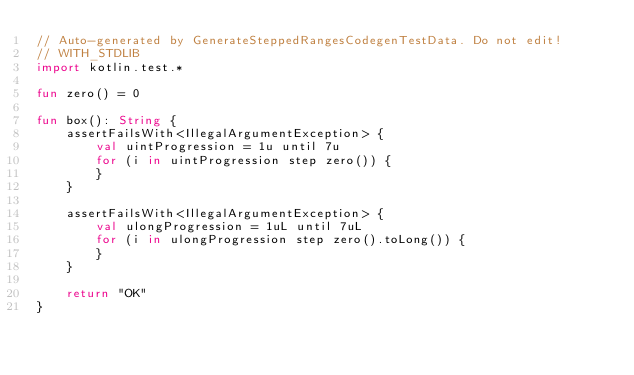Convert code to text. <code><loc_0><loc_0><loc_500><loc_500><_Kotlin_>// Auto-generated by GenerateSteppedRangesCodegenTestData. Do not edit!
// WITH_STDLIB
import kotlin.test.*

fun zero() = 0

fun box(): String {
    assertFailsWith<IllegalArgumentException> {
        val uintProgression = 1u until 7u
        for (i in uintProgression step zero()) {
        }
    }

    assertFailsWith<IllegalArgumentException> {
        val ulongProgression = 1uL until 7uL
        for (i in ulongProgression step zero().toLong()) {
        }
    }

    return "OK"
}</code> 